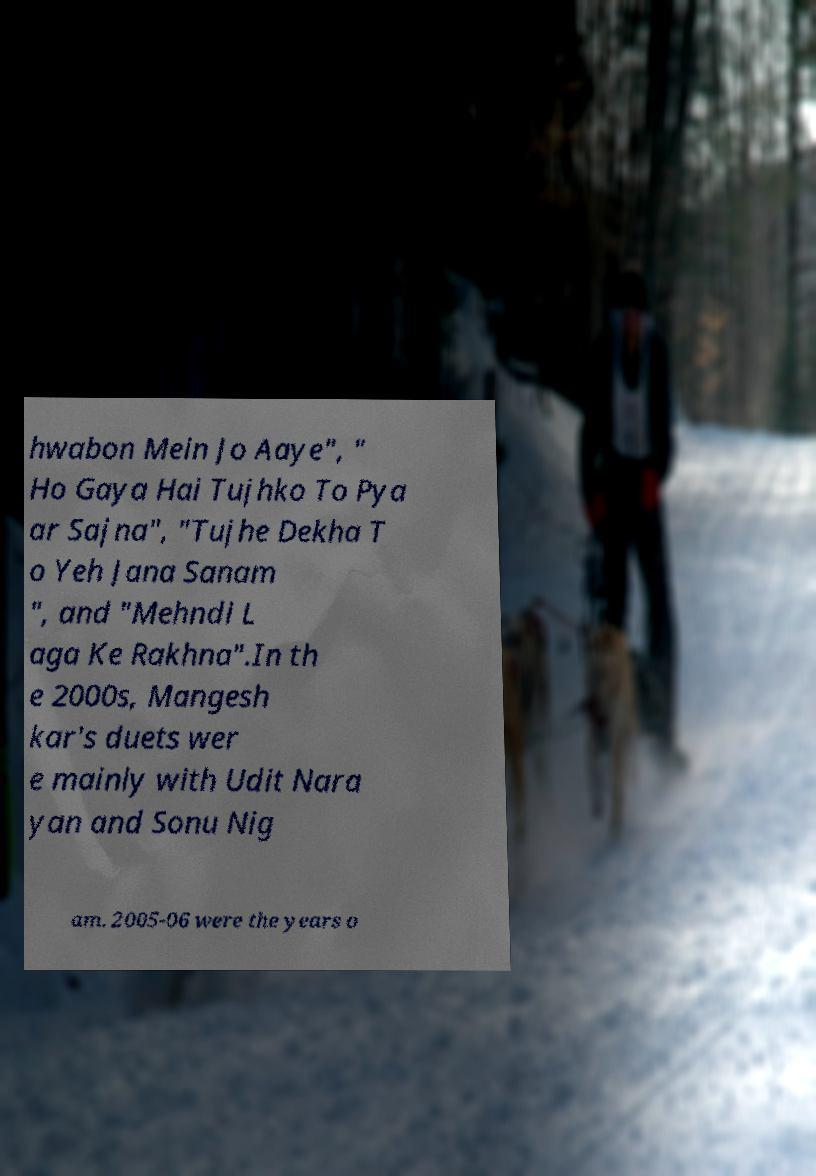Please read and relay the text visible in this image. What does it say? hwabon Mein Jo Aaye", " Ho Gaya Hai Tujhko To Pya ar Sajna", "Tujhe Dekha T o Yeh Jana Sanam ", and "Mehndi L aga Ke Rakhna".In th e 2000s, Mangesh kar's duets wer e mainly with Udit Nara yan and Sonu Nig am. 2005-06 were the years o 